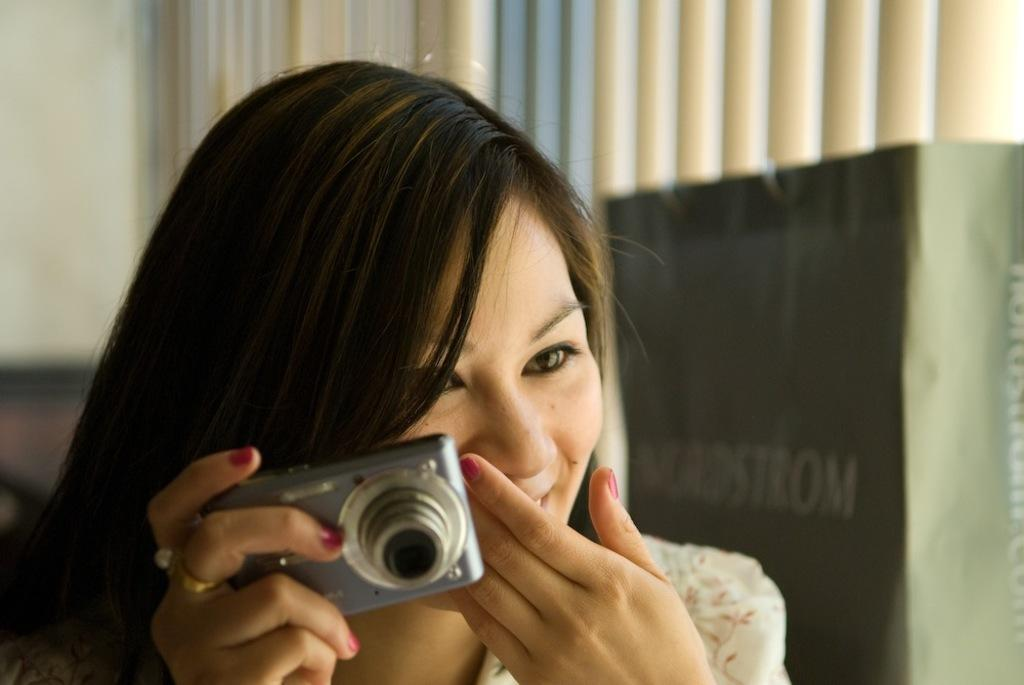Who is the main subject in the image? There is a woman in the image. What is the woman holding in her hand? The woman is holding a camera in her hand. Can you describe any other objects visible in the image? There is a bag visible in the background of the image. What type of operation is the woman performing on the cup in the image? There is no cup present in the image, and the woman is not performing any operation on any object. 